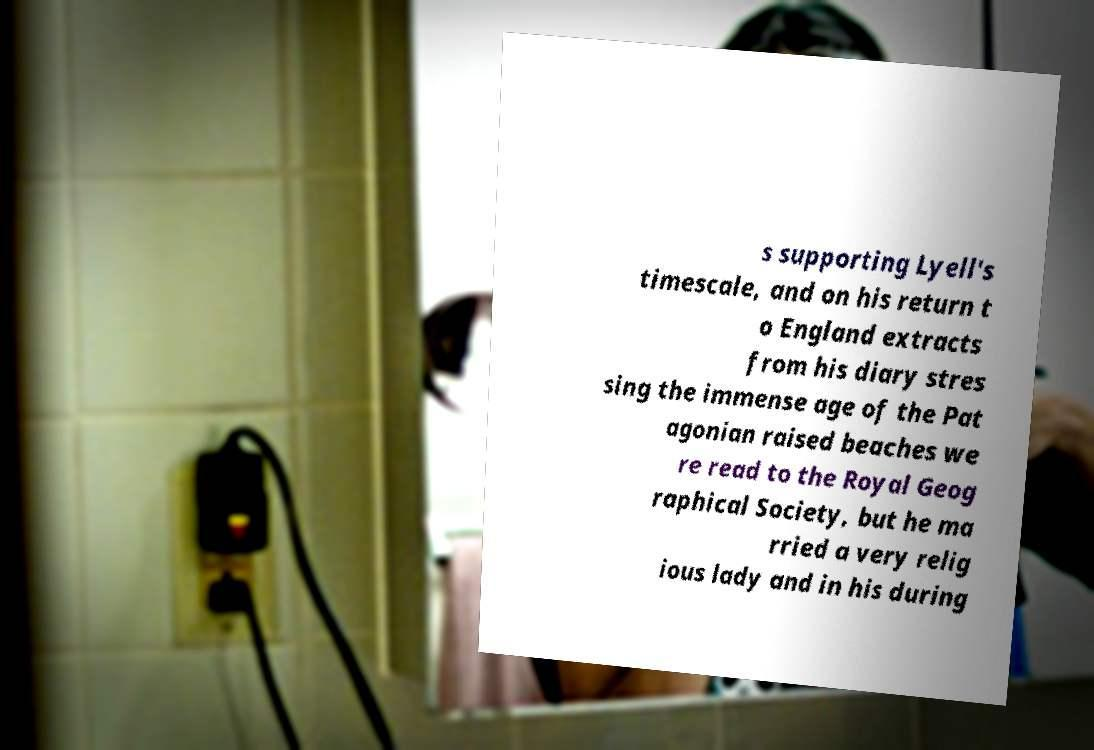Please read and relay the text visible in this image. What does it say? s supporting Lyell's timescale, and on his return t o England extracts from his diary stres sing the immense age of the Pat agonian raised beaches we re read to the Royal Geog raphical Society, but he ma rried a very relig ious lady and in his during 